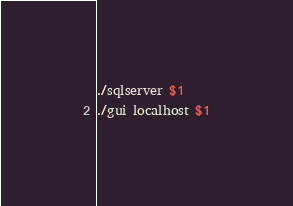Convert code to text. <code><loc_0><loc_0><loc_500><loc_500><_Bash_>./sqlserver $1
./gui localhost $1
</code> 